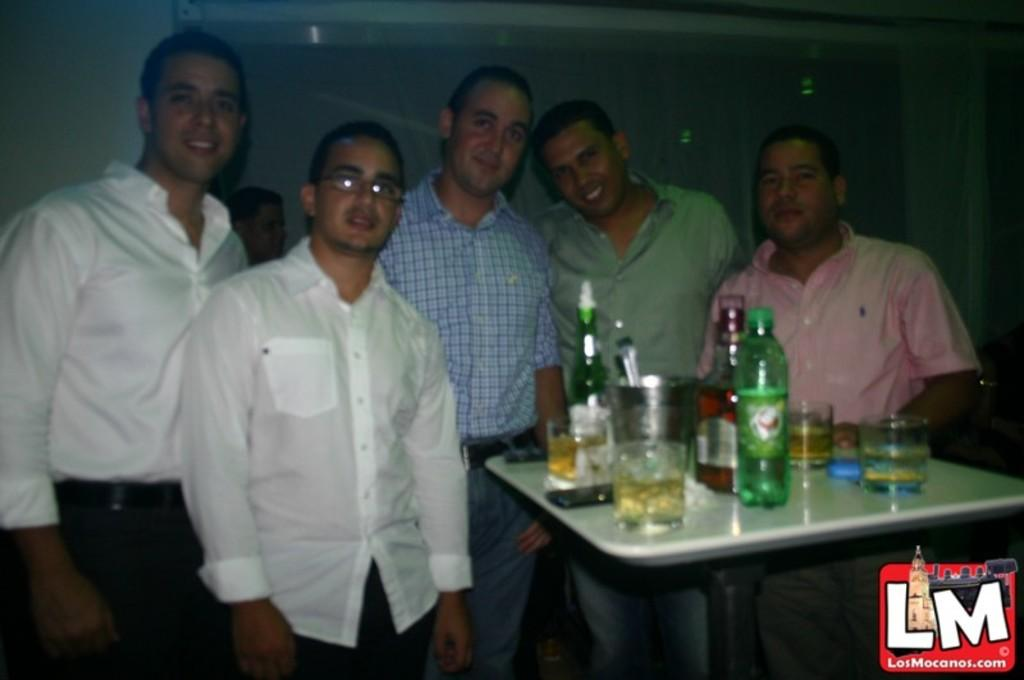How many people are in the image? There is a group of persons in the image. What are the people in the image doing? The persons are standing. What objects can be seen on the table in the image? There are bottles and glasses placed on a table in the image. What type of beast can be seen playing in harmony with the group of persons in the image? There is no beast present in the image, and the group of persons is not depicted as playing in harmony with any creature. 